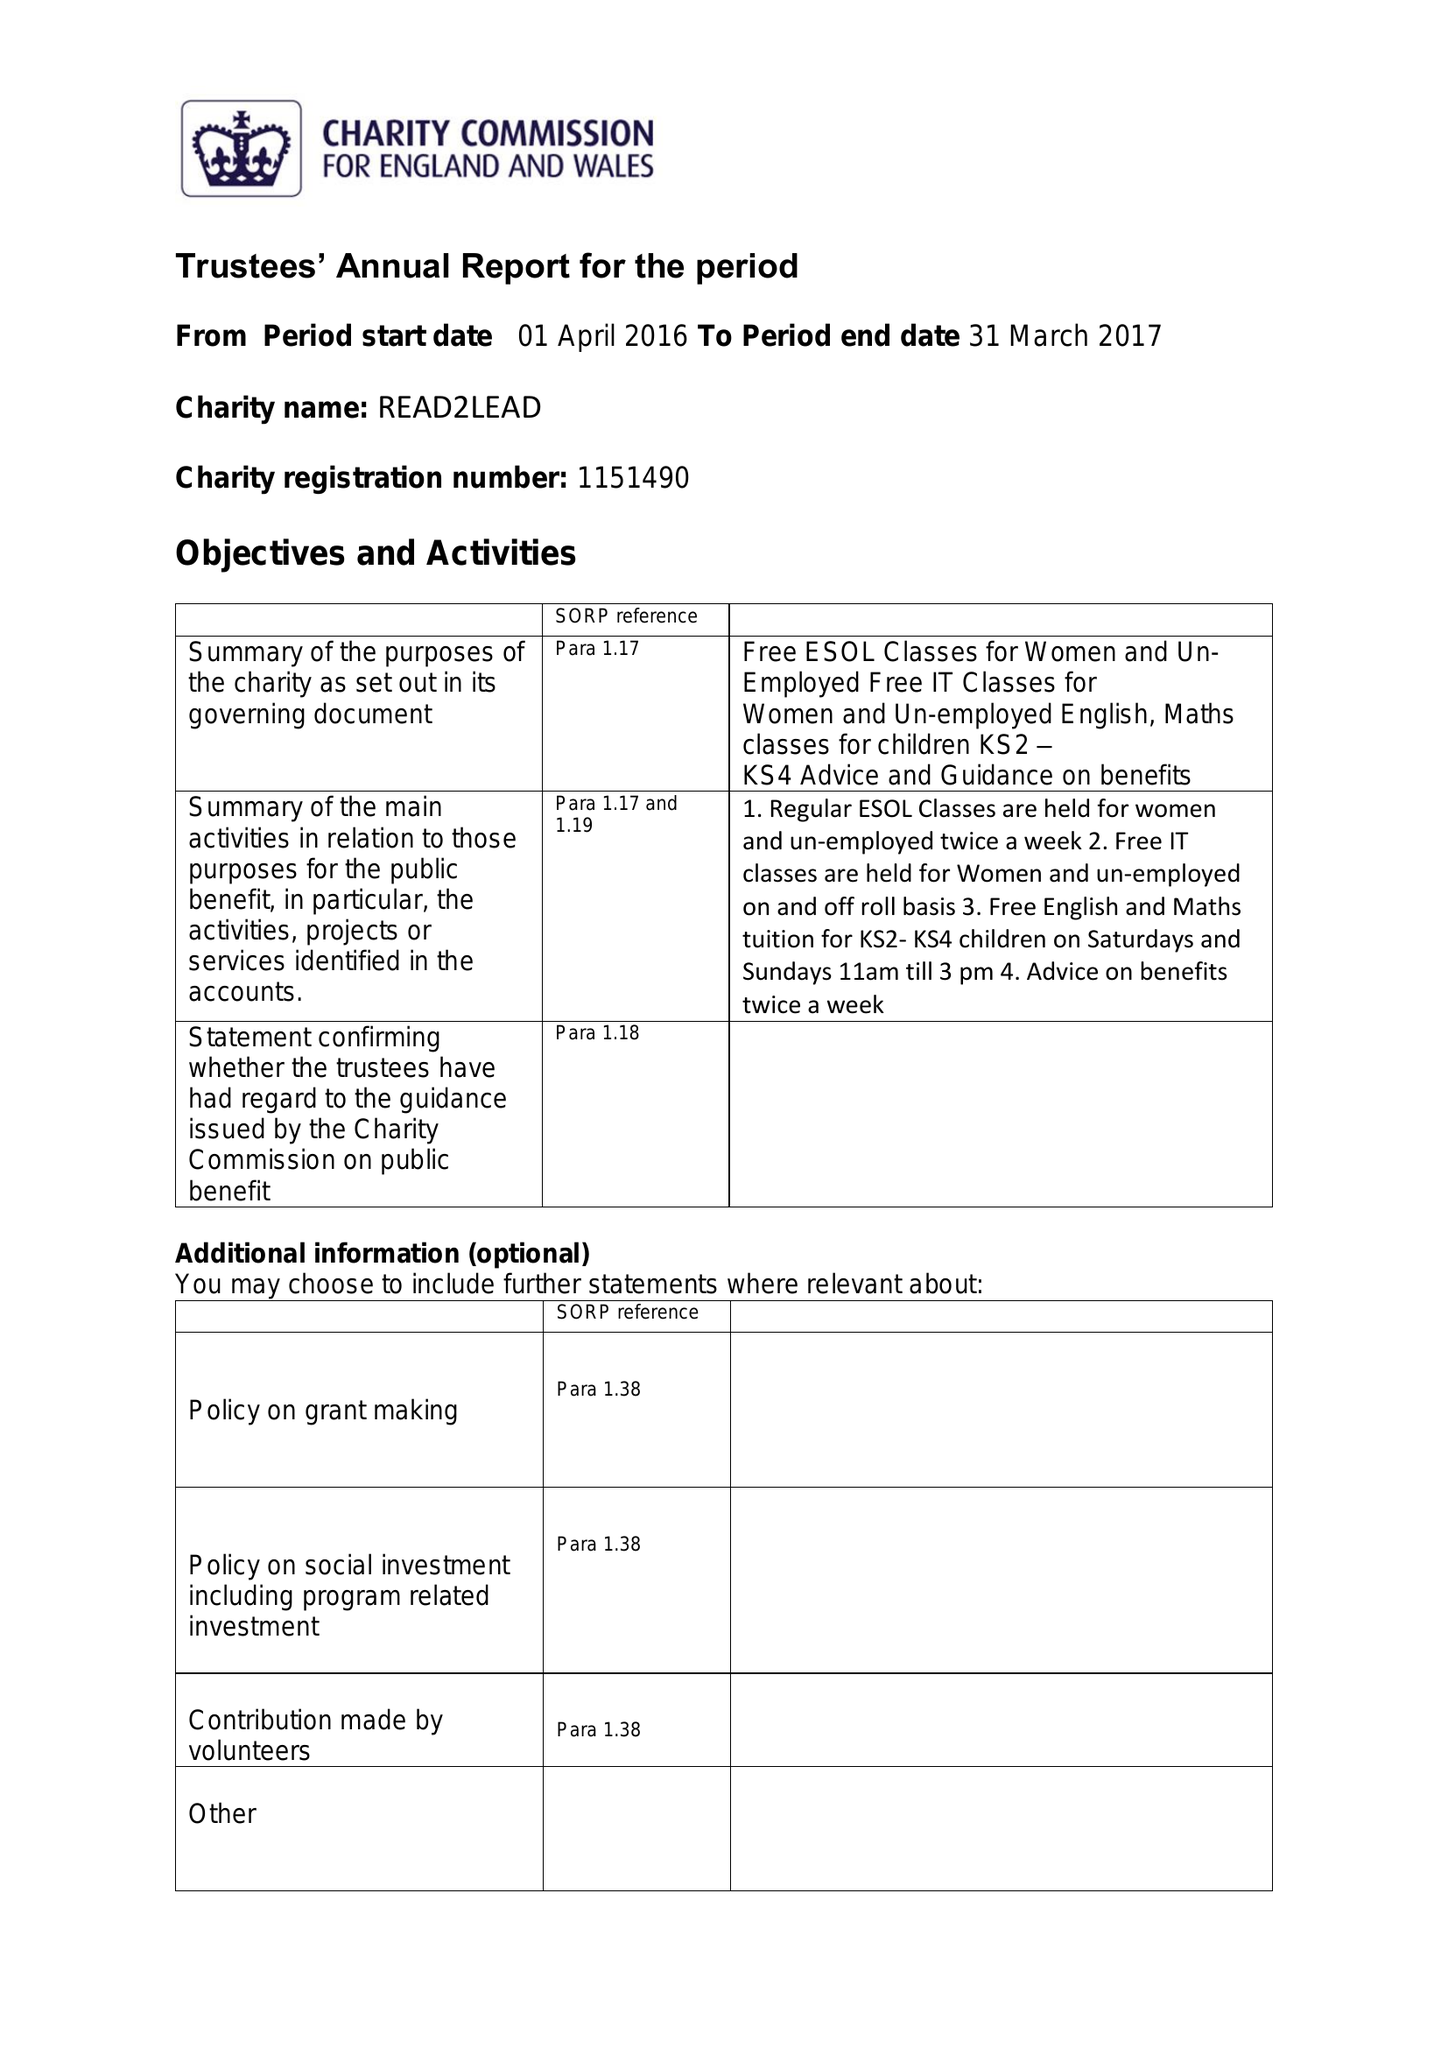What is the value for the charity_number?
Answer the question using a single word or phrase. 1151490 